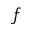Convert formula to latex. <formula><loc_0><loc_0><loc_500><loc_500>f</formula> 